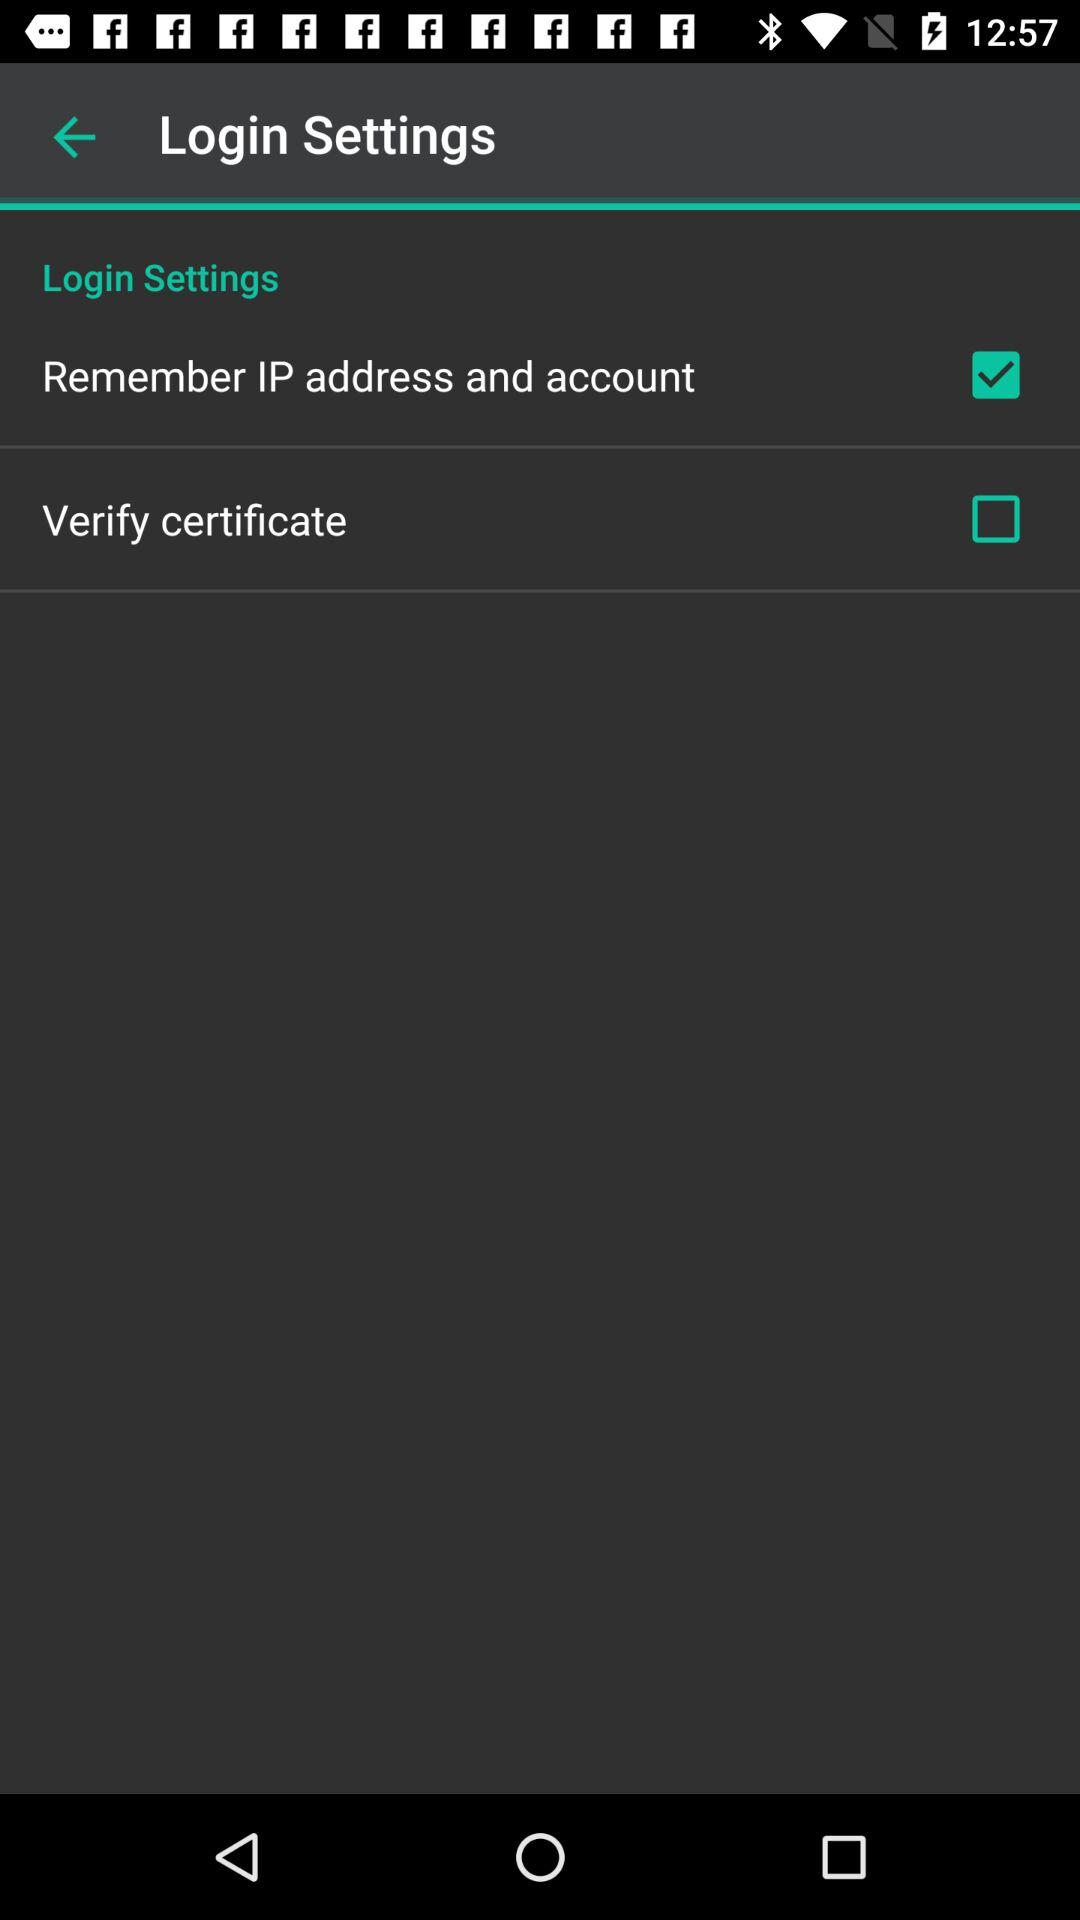What is the status of the "Remember IP address and account"? The status is on. 